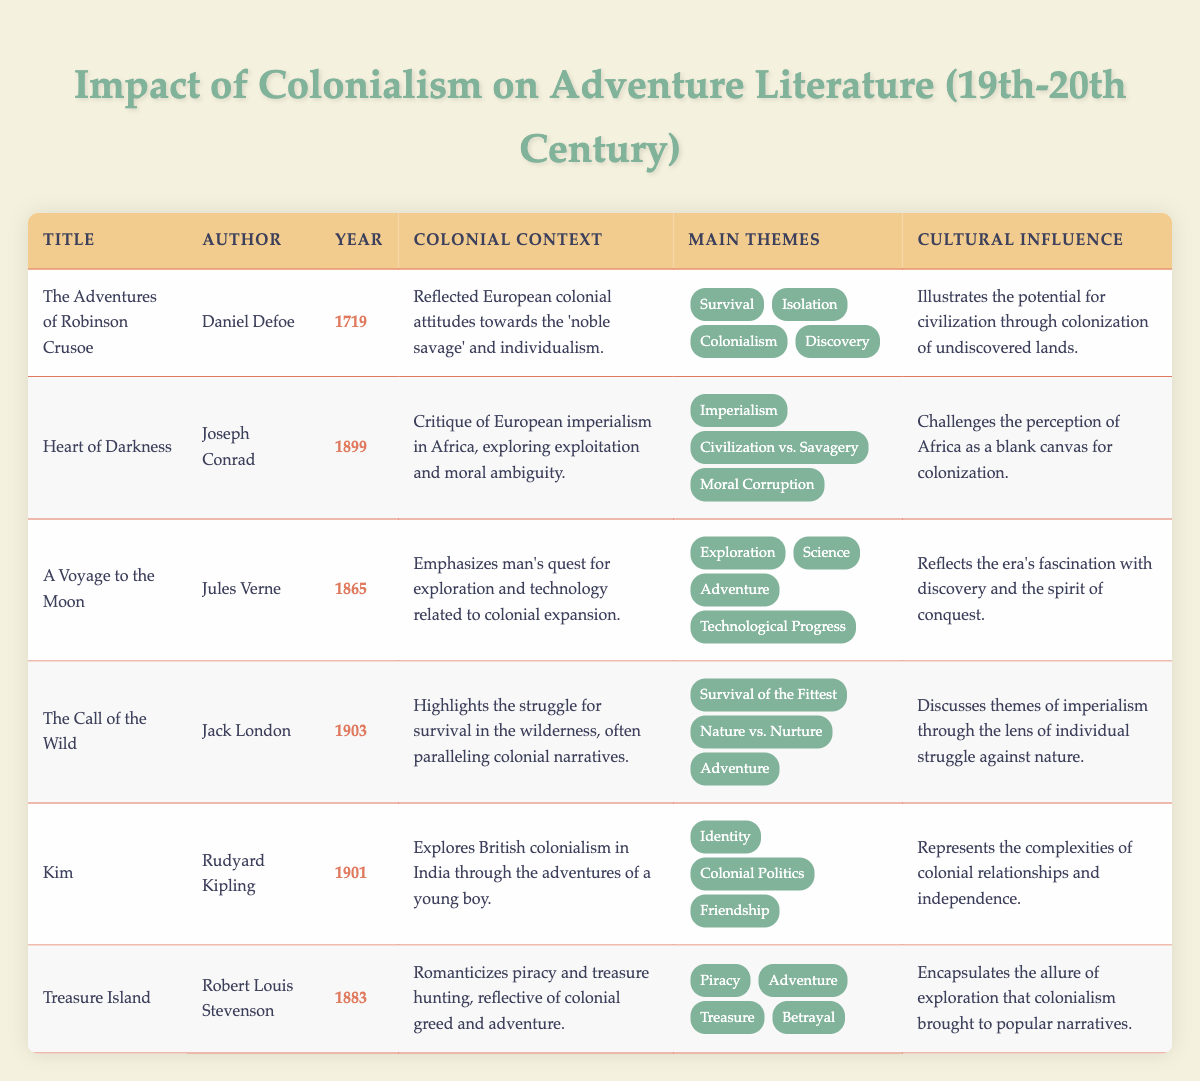What year was "The Call of the Wild" published? Look at the "Publication Year" column for "The Call of the Wild"; it shows 1903.
Answer: 1903 Which author wrote "Heart of Darkness"? In the "Author" column corresponding to "Heart of Darkness," it lists Joseph Conrad.
Answer: Joseph Conrad What are the main themes in "Treasure Island"? Checking the "Main Themes" column for "Treasure Island," the themes listed are Piracy, Adventure, Treasure, and Betrayal.
Answer: Piracy, Adventure, Treasure, Betrayal Did "A Voyage to the Moon" reflect colonial attitudes? In the "Colonial Context" for "A Voyage to the Moon," it describes man's quest for exploration and technology related to colonial expansion, which indicates a yes.
Answer: Yes Which work critiques European imperialism in Africa? From the "Colonial Context" column, "Heart of Darkness" is noted for its critique of European imperialism in Africa, making this a straightforward retrieval from the table.
Answer: Heart of Darkness What is the total number of works listed that mention "Colonialism" as a main theme? By scanning the "Main Themes" column for each title, we find that "The Adventures of Robinson Crusoe," "Kim," and "Heart of Darkness" all mention "Colonialism." This gives us a total of 3 works.
Answer: 3 Name the titles published after 1900 that discuss imperialism. Filtering the "Publication Year" and looking specifically for entries after 1900, both "The Call of the Wild" (1903) and "Kim" (1901) discuss themes related to imperialism. Therefore, the answer includes these two titles.
Answer: The Call of the Wild, Kim Is "Treasure Island" associated with the romanticization of piracy? The "Colonial Context" for "Treasure Island" states that it romanticizes piracy and treasure hunting, leading to a yes answer to the statement.
Answer: Yes What are the cultural influences of "Heart of Darkness"? The "Cultural Influence" column for "Heart of Darkness" explains that it challenges the perception of Africa as a blank canvas for colonization. Thus, the influence is clearly stated in the table.
Answer: Challenges the perception of Africa as a blank canvas for colonization 